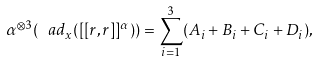<formula> <loc_0><loc_0><loc_500><loc_500>\alpha ^ { \otimes 3 } ( \ a d _ { x } ( [ [ r , r ] ] ^ { \alpha } ) ) = \sum _ { i = 1 } ^ { 3 } ( A _ { i } + B _ { i } + C _ { i } + D _ { i } ) ,</formula> 